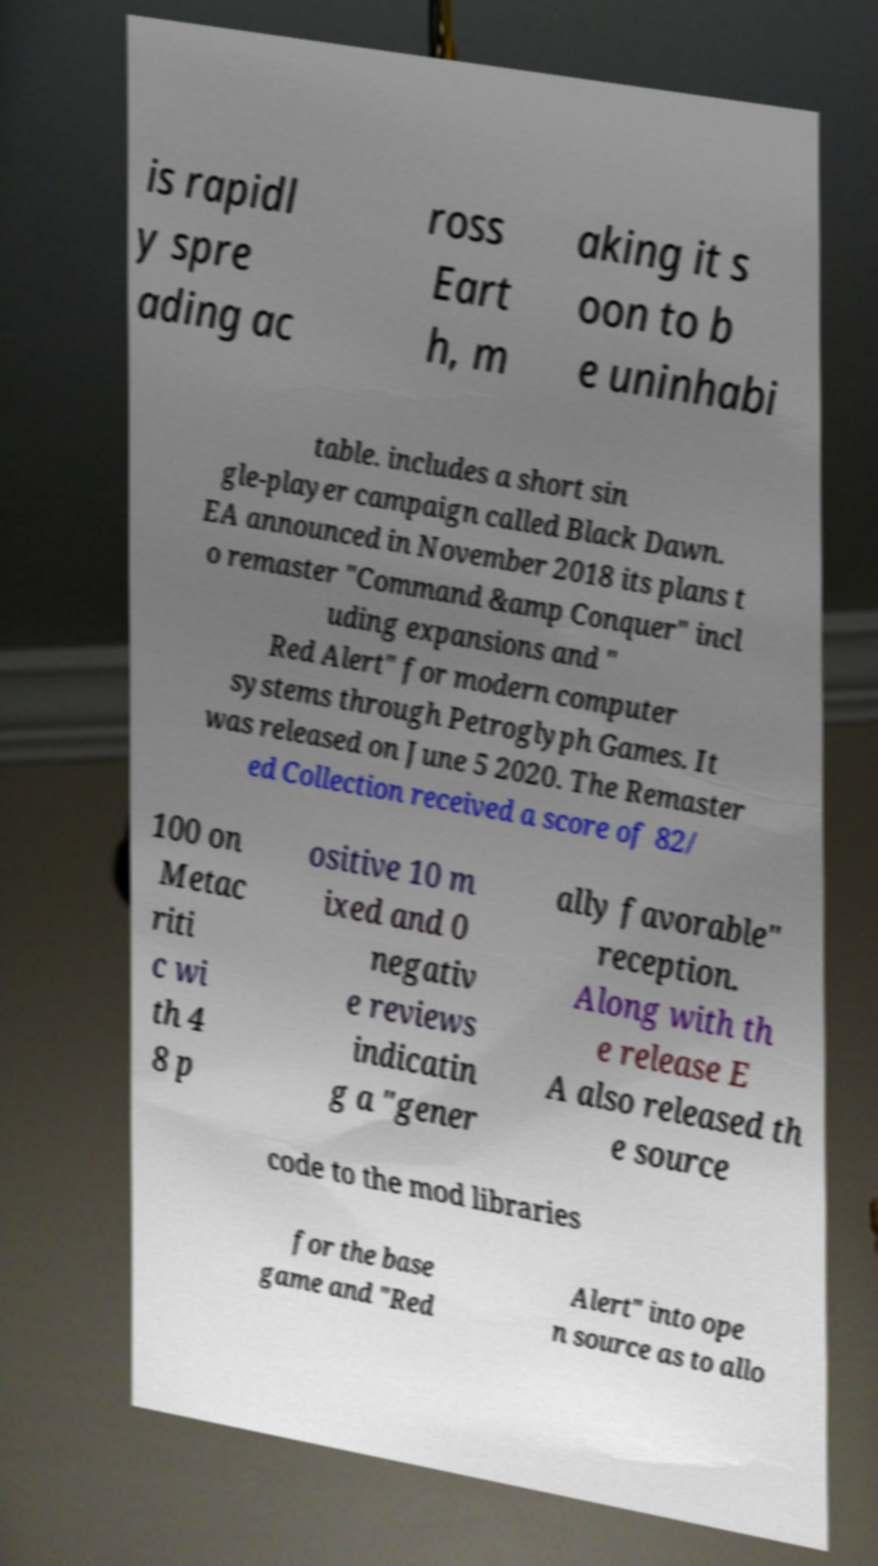For documentation purposes, I need the text within this image transcribed. Could you provide that? is rapidl y spre ading ac ross Eart h, m aking it s oon to b e uninhabi table. includes a short sin gle-player campaign called Black Dawn. EA announced in November 2018 its plans t o remaster "Command &amp Conquer" incl uding expansions and " Red Alert" for modern computer systems through Petroglyph Games. It was released on June 5 2020. The Remaster ed Collection received a score of 82/ 100 on Metac riti c wi th 4 8 p ositive 10 m ixed and 0 negativ e reviews indicatin g a "gener ally favorable" reception. Along with th e release E A also released th e source code to the mod libraries for the base game and "Red Alert" into ope n source as to allo 